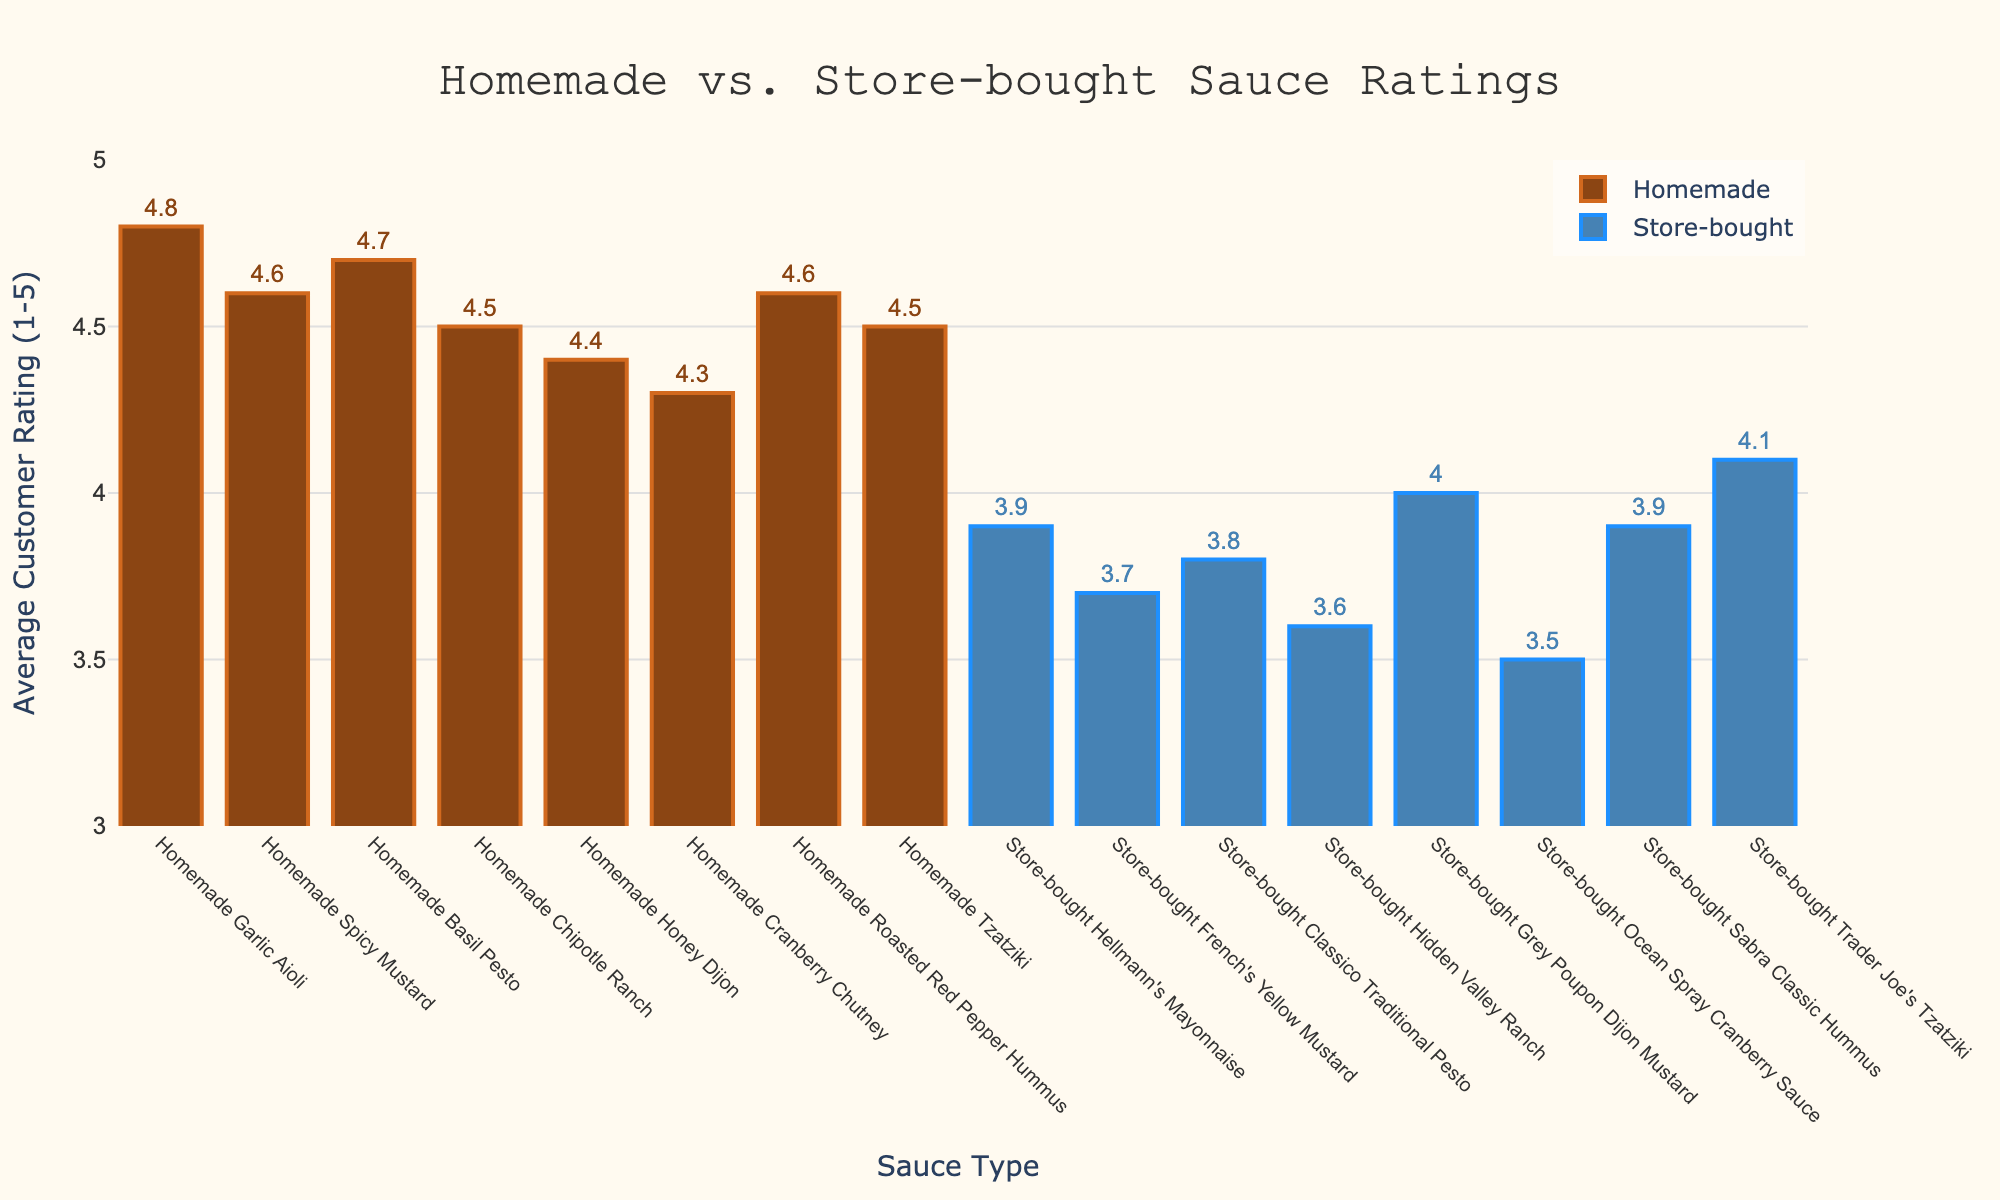What's the highest average customer rating for a homemade sauce? To find the highest rating for a homemade sauce, we locate the tallest bar labeled as homemade on the plot. The homemade garlic aioli has the highest bar with an average rating of 4.8.
Answer: 4.8 What's the difference in average customer rating between Homemade Garlic Aioli and Store-bought Hellmann's Mayonnaise? Subtract the rating of the store-bought mayonnaise from the homemade garlic aioli rating: 4.8 (Homemade Garlic Aioli) - 3.9 (Store-bought Hellmann's Mayonnaise) = 0.9
Answer: 0.9 Which homemade sauce has the lowest average customer rating? To determine this, we look for the shortest bar among the homemade sauces on the plot. The homemade cranberry chutney has the shortest bar, with an average rating of 4.3.
Answer: 4.3 Which store-bought sauce has a higher average rating: Trader Joe's Tzatziki or Sabra Classic Hummus? Compare the heights of the bars for Trader Joe's Tzatziki and Sabra Classic Hummus. Trader Joe's Tzatziki has an average rating of 4.1, whereas Sabra Classic Hummus has 3.9. Therefore, Trader Joe's Tzatziki has a higher rating.
Answer: Trader Joe's Tzatziki What is the overall average rating of all homemade sauces? Sum all the average ratings of the homemade sauces and divide by the total number of homemade sauces: (4.8 + 4.6 + 4.7 + 4.5 + 4.4 + 4.3 + 4.6 + 4.5) / 8 = 36.4 / 8 = 4.55
Answer: 4.55 By how much does the average rating of homemade sauces exceed that of store-bought sauces? First, calculate the average rating for each group. The average for homemade sauces is 4.55 (as calculated before). For store-bought sauces: (3.9 + 3.7 + 3.8 + 3.6 + 4.0 + 3.5 + 3.9 + 4.1) / 8 = 30.5 / 8 = 3.8125. Then subtract the store-bought average from the homemade average: 4.55 - 3.8125 = 0.7375
Answer: 0.7375 Which store-bought sauce has the lowest average customer rating? Look for the shortest bar among the store-bought sauces. The store-bought Ocean Spray Cranberry Sauce has the shortest bar with an average rating of 3.5.
Answer: 3.5 How many homemade sauces have a higher average rating than Grey Poupon Dijon Mustard? Grey Poupon Dijon Mustard has an average rating of 4.0. Count the number of homemade sauces with bars higher than this which are 7 in total (all except homemade cranberry chutney).
Answer: 7 Is there any store-bought sauce with an average rating of 4.0 or higher? Compare the ratings of all store-bought sauces. Grey Poupon Dijon Mustard (4.0) and Trader Joe's Tzatziki (4.1) meet this criterion.
Answer: Yes, two: Grey Poupon Dijon Mustard and Trader Joe's Tzatziki 